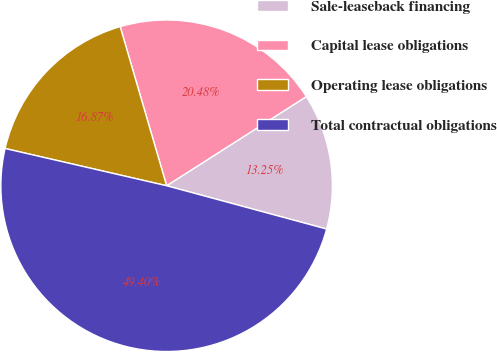Convert chart. <chart><loc_0><loc_0><loc_500><loc_500><pie_chart><fcel>Sale-leaseback financing<fcel>Capital lease obligations<fcel>Operating lease obligations<fcel>Total contractual obligations<nl><fcel>13.25%<fcel>20.48%<fcel>16.87%<fcel>49.4%<nl></chart> 